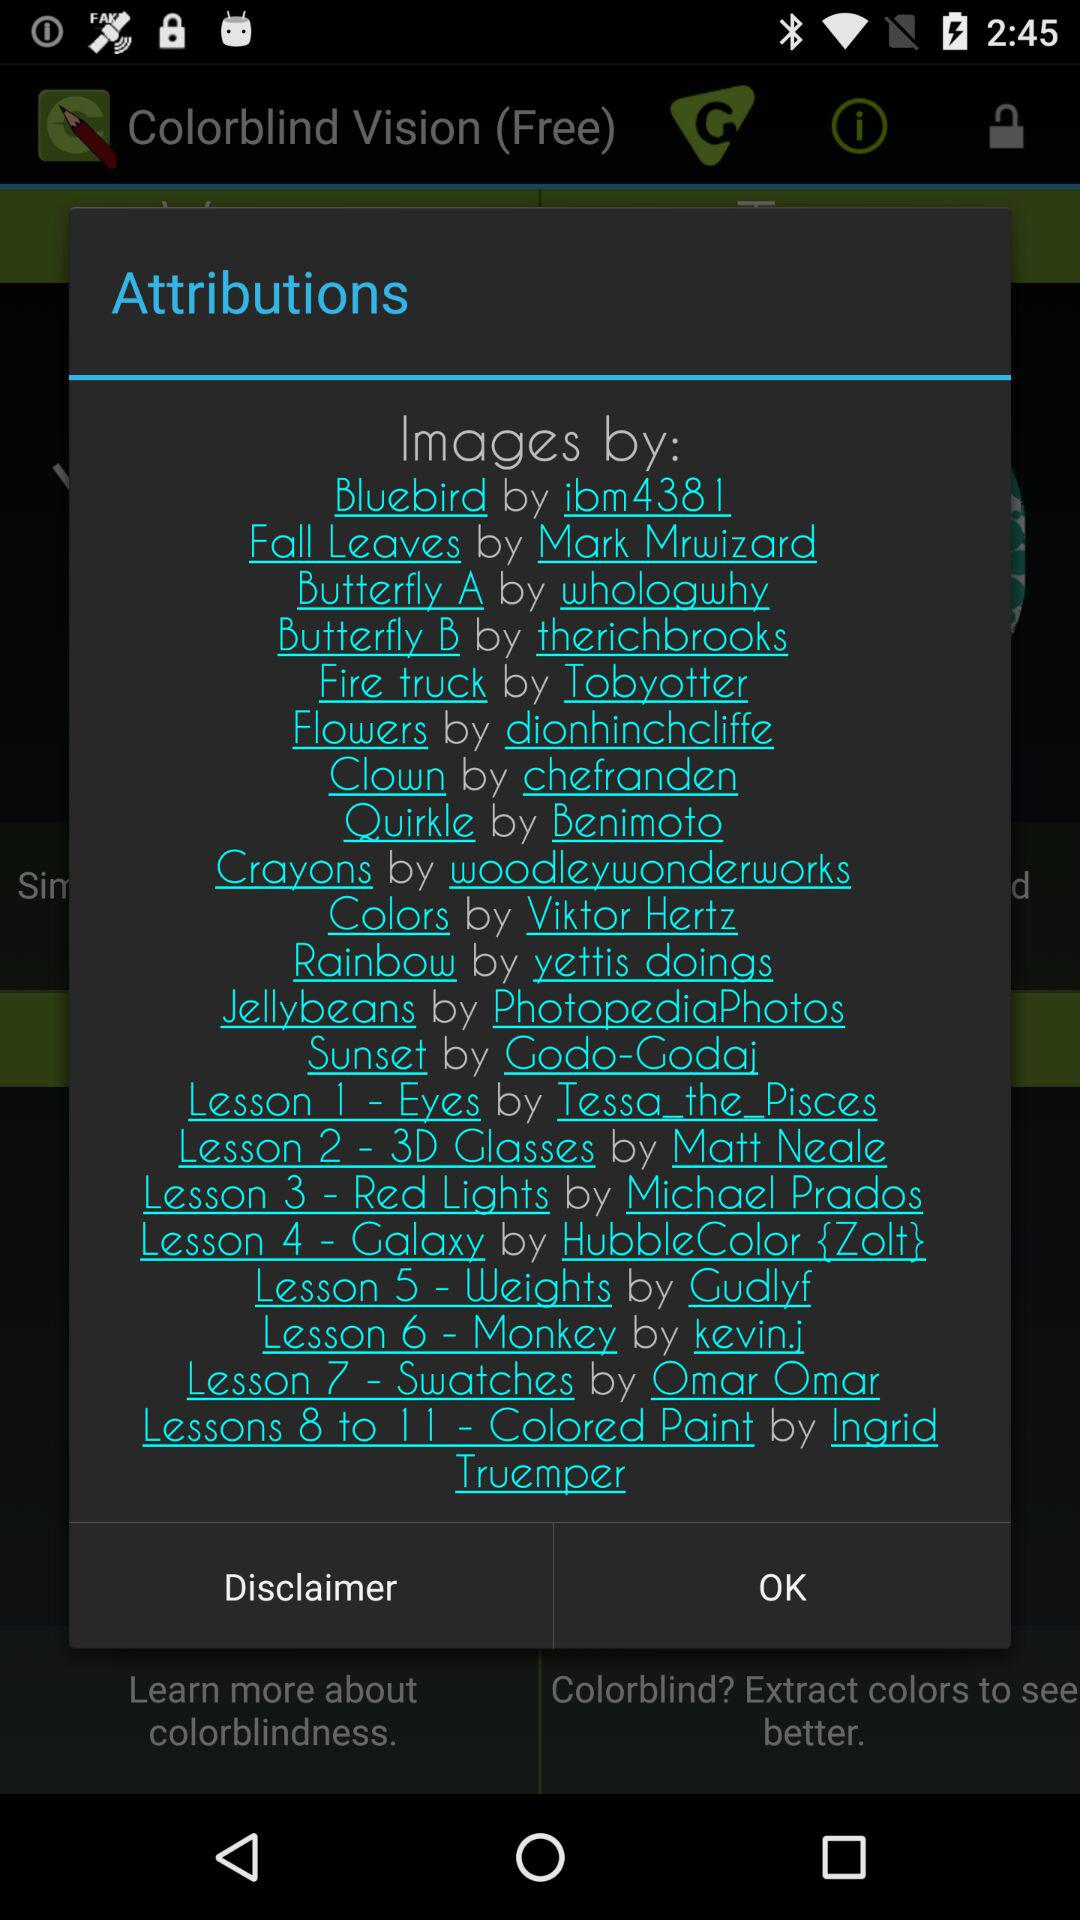How many lessons are there in the app?
Answer the question using a single word or phrase. 11 